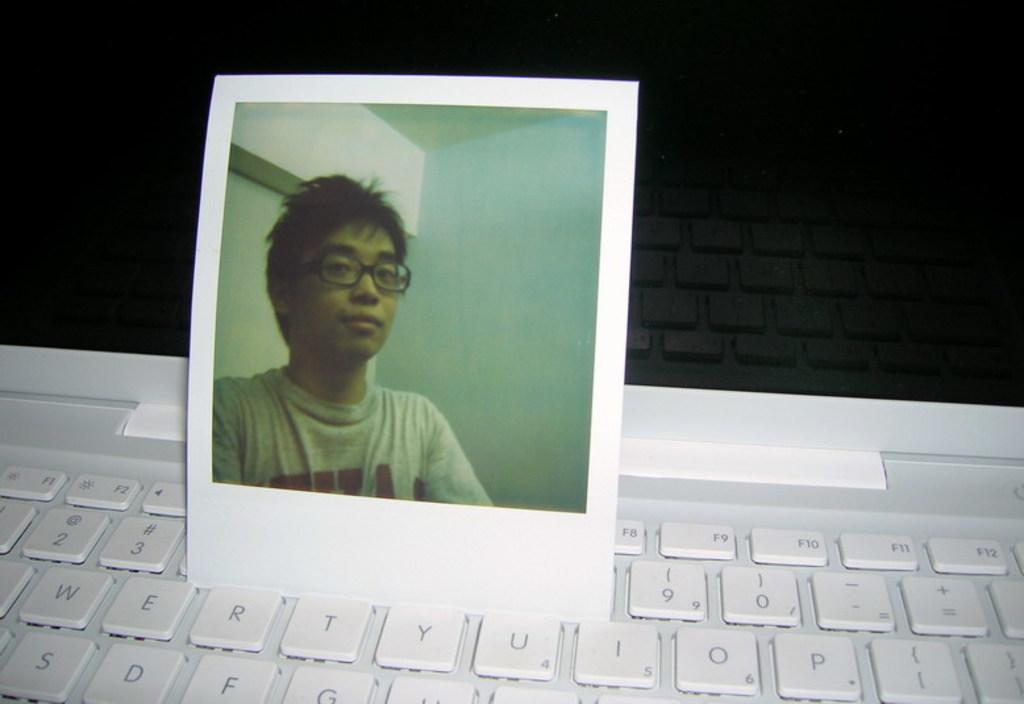What is the main subject of the image? The main subject of the image is a photograph of a boy. Where is the photograph located? The photograph is on a laptop. How many lizards can be seen crawling on the laptop in the image? There are no lizards present in the image. What letter does the boy's name start with in the photograph? We cannot determine the boy's name or the first letter of his name from the image. 